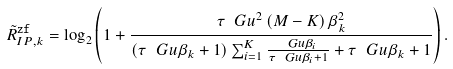Convert formula to latex. <formula><loc_0><loc_0><loc_500><loc_500>\tilde { R } _ { I P , k } ^ { \tt { z f } } = \log _ { 2 } \left ( 1 + \frac { \tau \ G u ^ { 2 } \left ( M - K \right ) \beta _ { k } ^ { 2 } } { \left ( \tau \ G u \beta _ { k } + 1 \right ) \sum _ { i = 1 } ^ { K } \frac { \ G u \beta _ { i } } { \tau \ G u \beta _ { i } + 1 } + \tau \ G u \beta _ { k } + 1 } \right ) .</formula> 